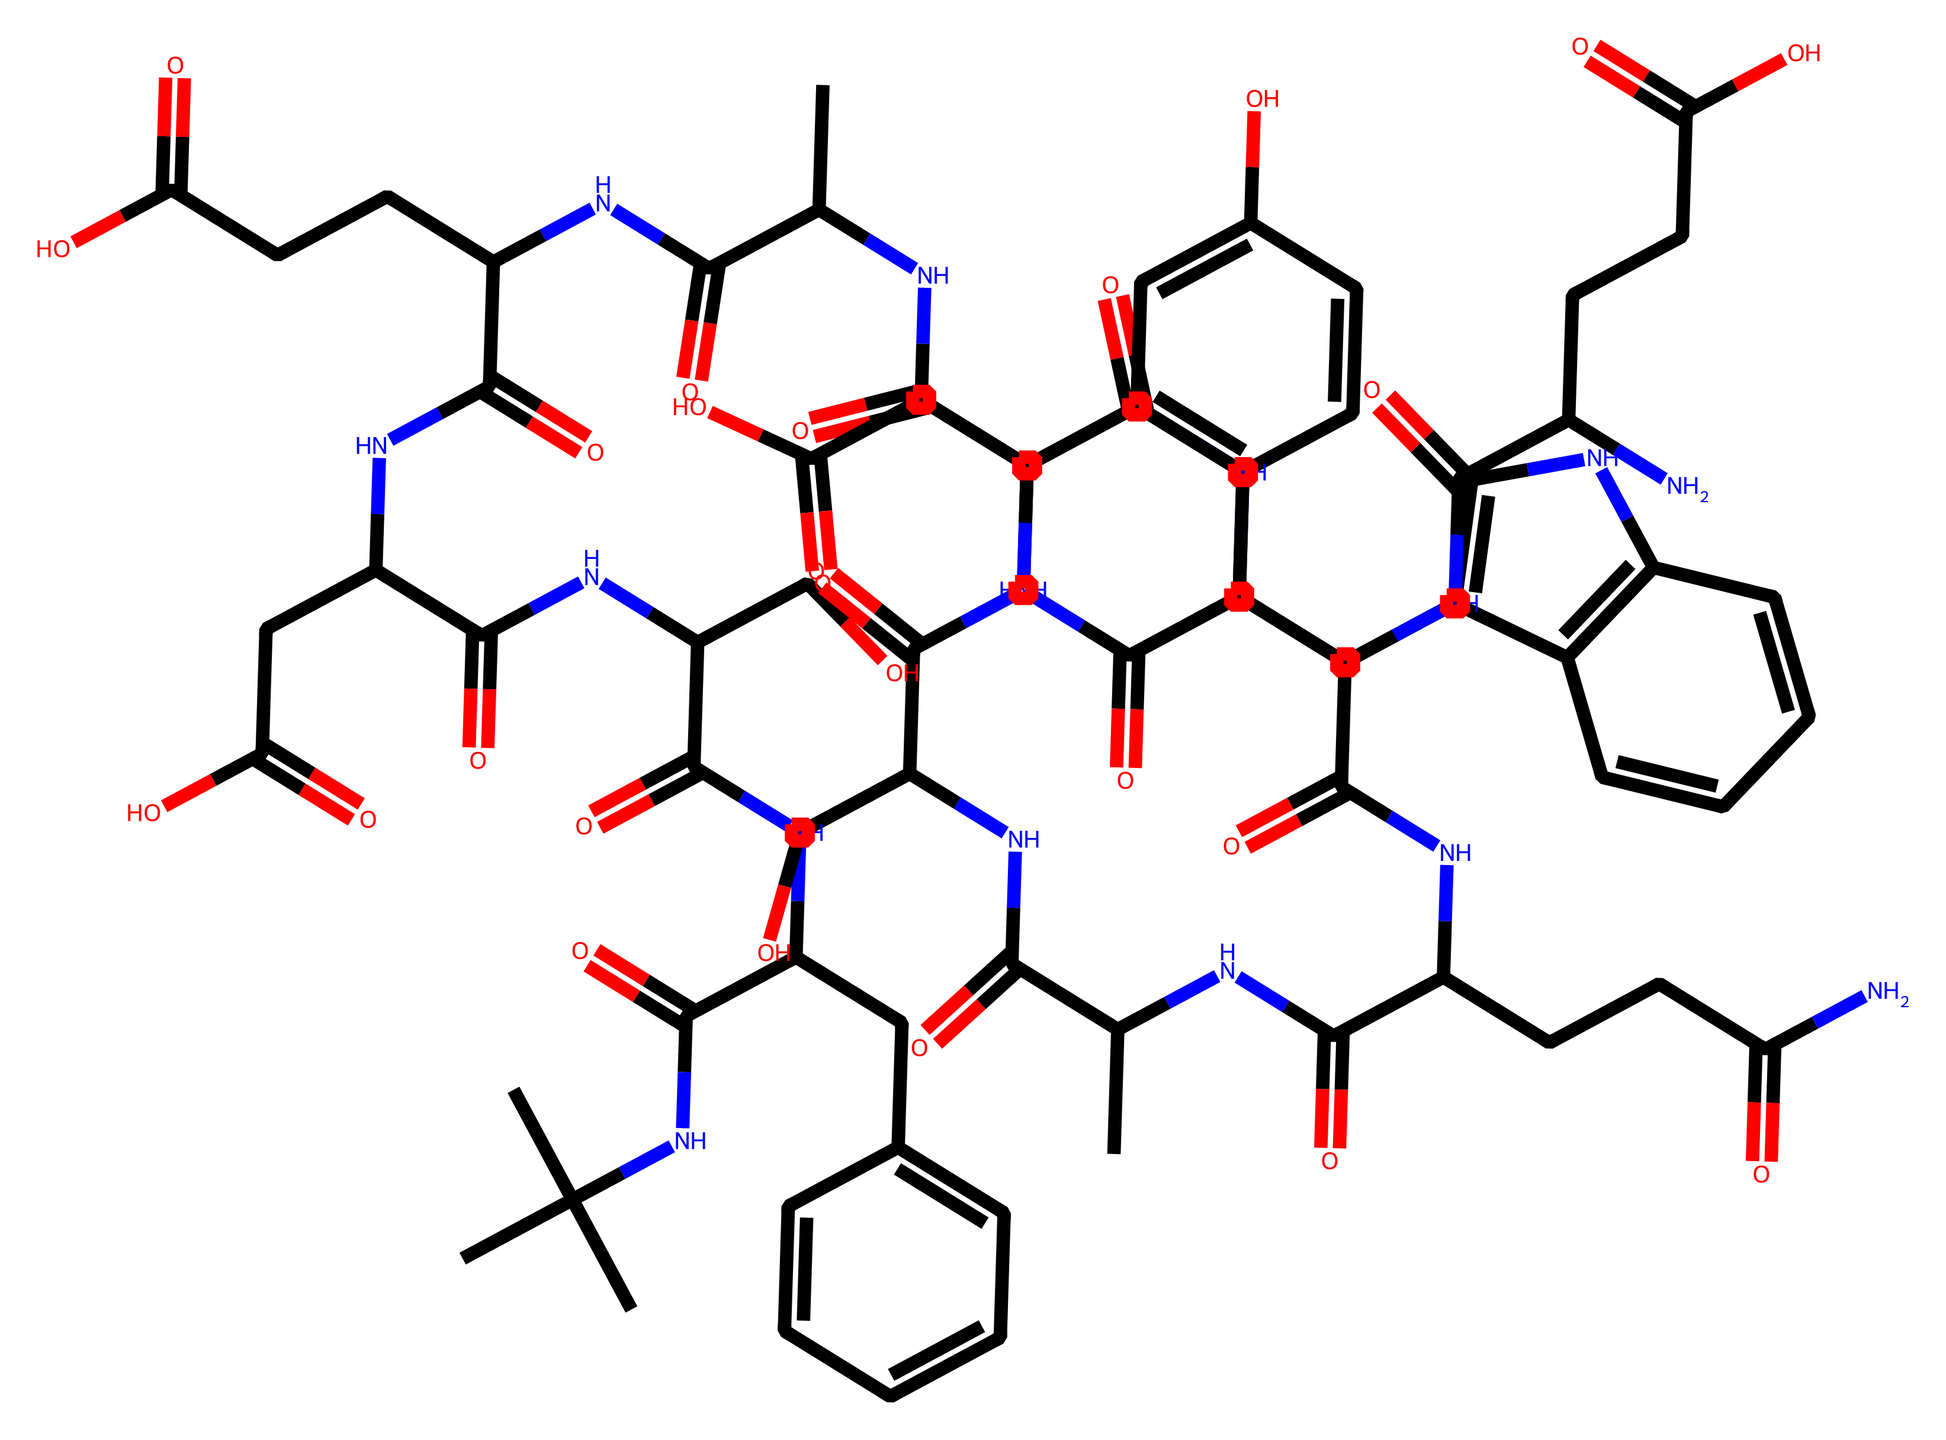What is the primary element in the backbone of collagen? The backbone of collagen primarily consists of carbon, oxygen, and nitrogen atoms, which are the main components of the amino acids that form collagen's structure.
Answer: carbon How many nitrogen atoms are present in this chemical structure? By examining the SMILES representation, we can identify that nitrogen atoms appear as 'N' in the structure. Counting them reveals that there are a total of 14 nitrogen atoms in the chain.
Answer: 14 What is the function of the hydroxyl groups in collagen? The hydroxyl groups (–OH) contribute to the hydrogen bonding between collagen molecules, enhancing the stability and strength of the collagen fibers, which is important for skin elasticity.
Answer: stability How many total carbon atoms can be found in the structure? The number of carbon atoms can be determined by counting each 'C' in the SMILES string. A detailed count shows that there are 49 carbon atoms in total.
Answer: 49 What type of structure does collagen form at a molecular level? Collagen typically forms a triple helix structure, where three polypeptide chains intertwine, providing strength and resilience to the tissue it composes.
Answer: triple helix Which part of the structure is involved in elasticity? The presence of cross-linking amino acids and specific functional groups, particularly where the nitrogen and carbon atoms are connected, contributes to the elasticity of collagen fibers.
Answer: cross-linking 